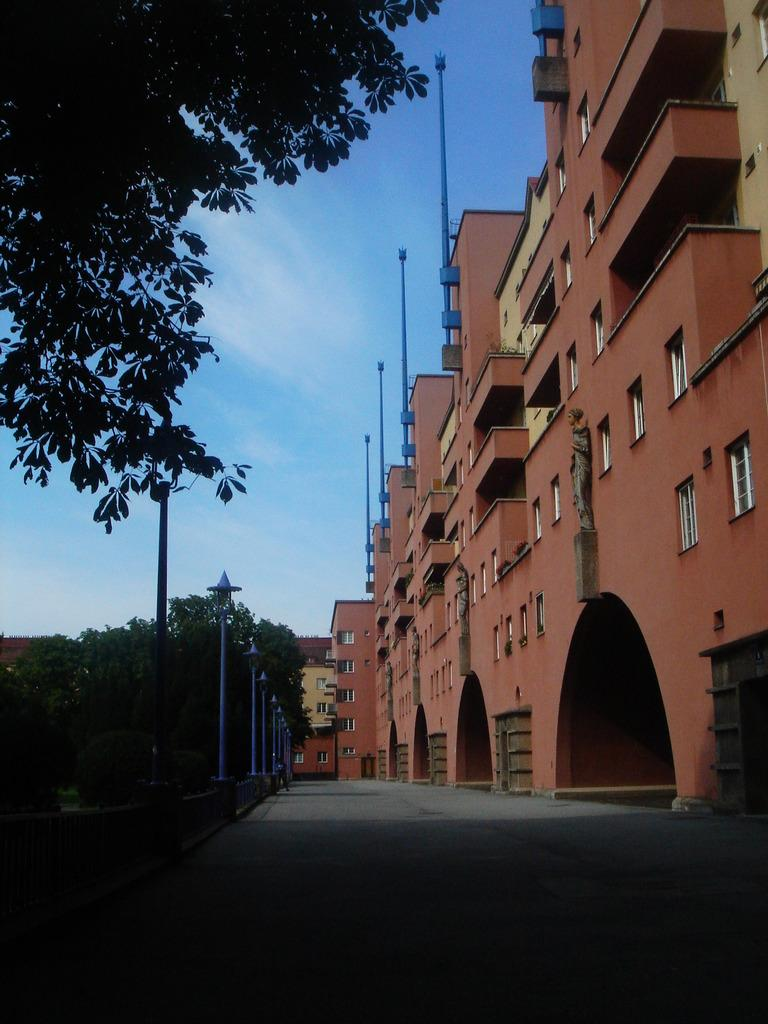What type of structures can be seen in the image? There are buildings in the image. What other natural elements are present in the image? There are trees in the image. What are the tall, thin objects in the image? There are poles in the image. What is visible at the top of the image? The sky is visible at the top of the image. What is located at the bottom of the image? There is a road at the bottom of the image. Can you tell me which book the grandfather is reading in the image? There is no book or grandfather present in the image. How does the fly navigate through the buildings in the image? There are no flies present in the image; it only features buildings, trees, poles, the sky, and a road. 